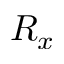<formula> <loc_0><loc_0><loc_500><loc_500>R _ { x }</formula> 